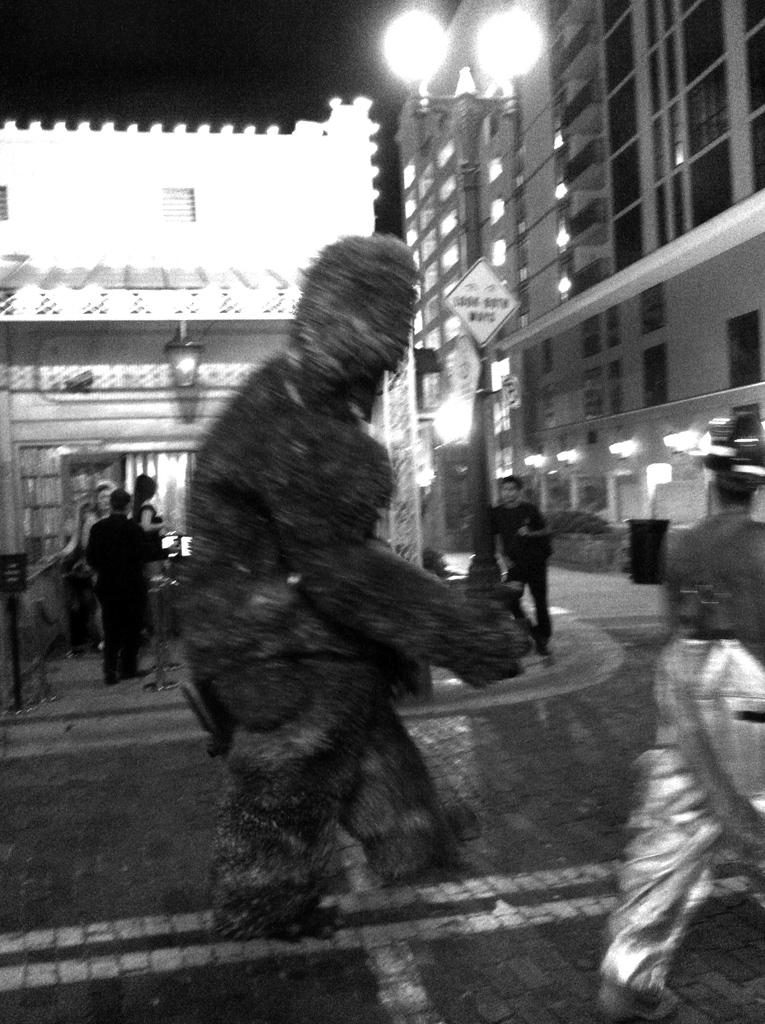What type of structures can be seen in the image? There are buildings in the image. What can be observed illuminating the scene in the image? There are lights visible in the image. What are the people in the image doing? There are people standing and walking in the image. What is the weather like in the image? The sky is cloudy in the image. What is written or displayed on the board in the image? There is a board with text in the image. Where is the chicken located in the image? There is no chicken present in the image. What type of park can be seen in the image? There is no park present in the image. 